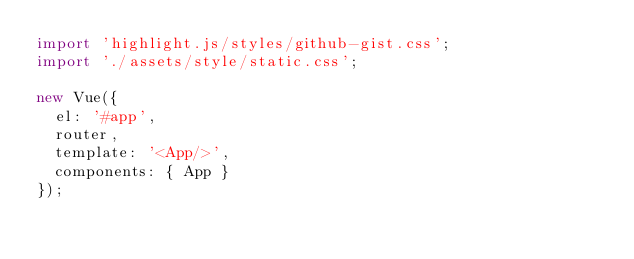<code> <loc_0><loc_0><loc_500><loc_500><_JavaScript_>import 'highlight.js/styles/github-gist.css';
import './assets/style/static.css';

new Vue({
  el: '#app',
  router,
  template: '<App/>',
  components: { App }
});
</code> 